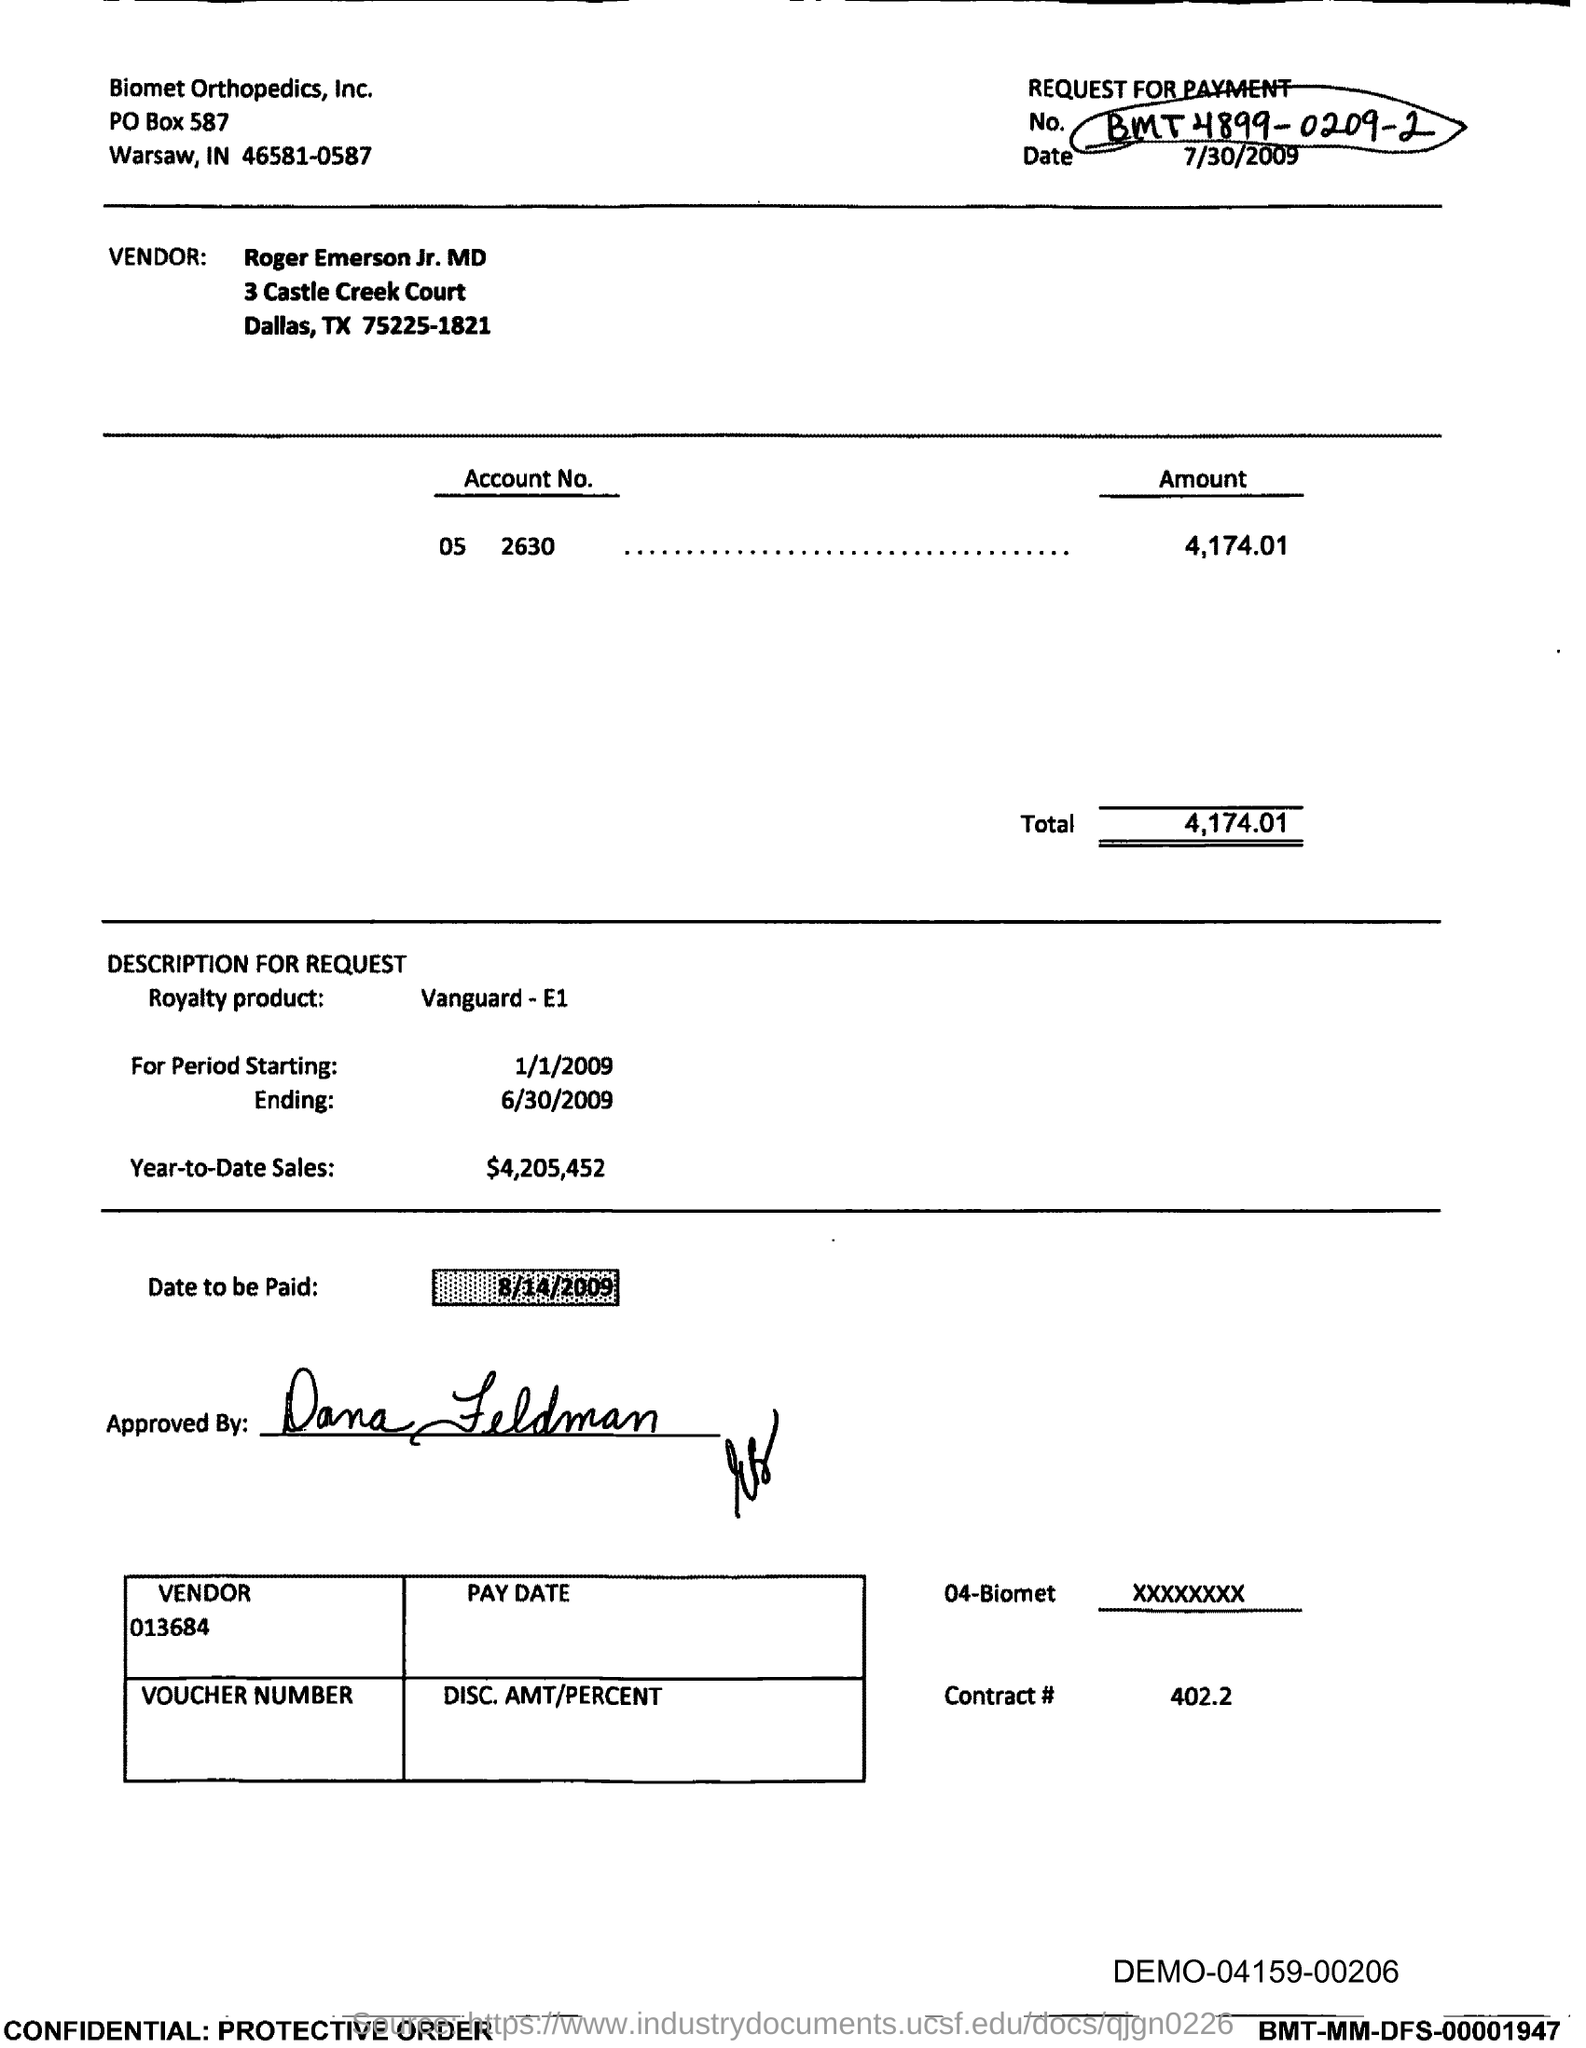Identify some key points in this picture. What is the date to be paid? On August 14th of 2009. The PO box number of Biomet Orthopedics, Inc. is 587. The total is 4,174.01. Biomet Orthopedics, Inc. is located in the state of Indiana. The vendor number is 013684... 